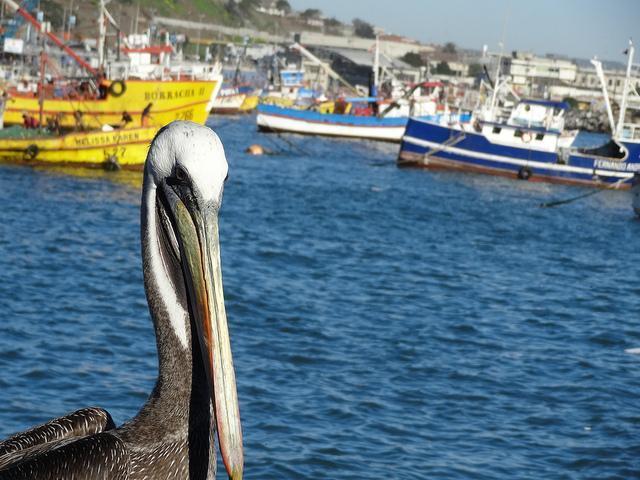How many boats are in the picture?
Give a very brief answer. 4. 